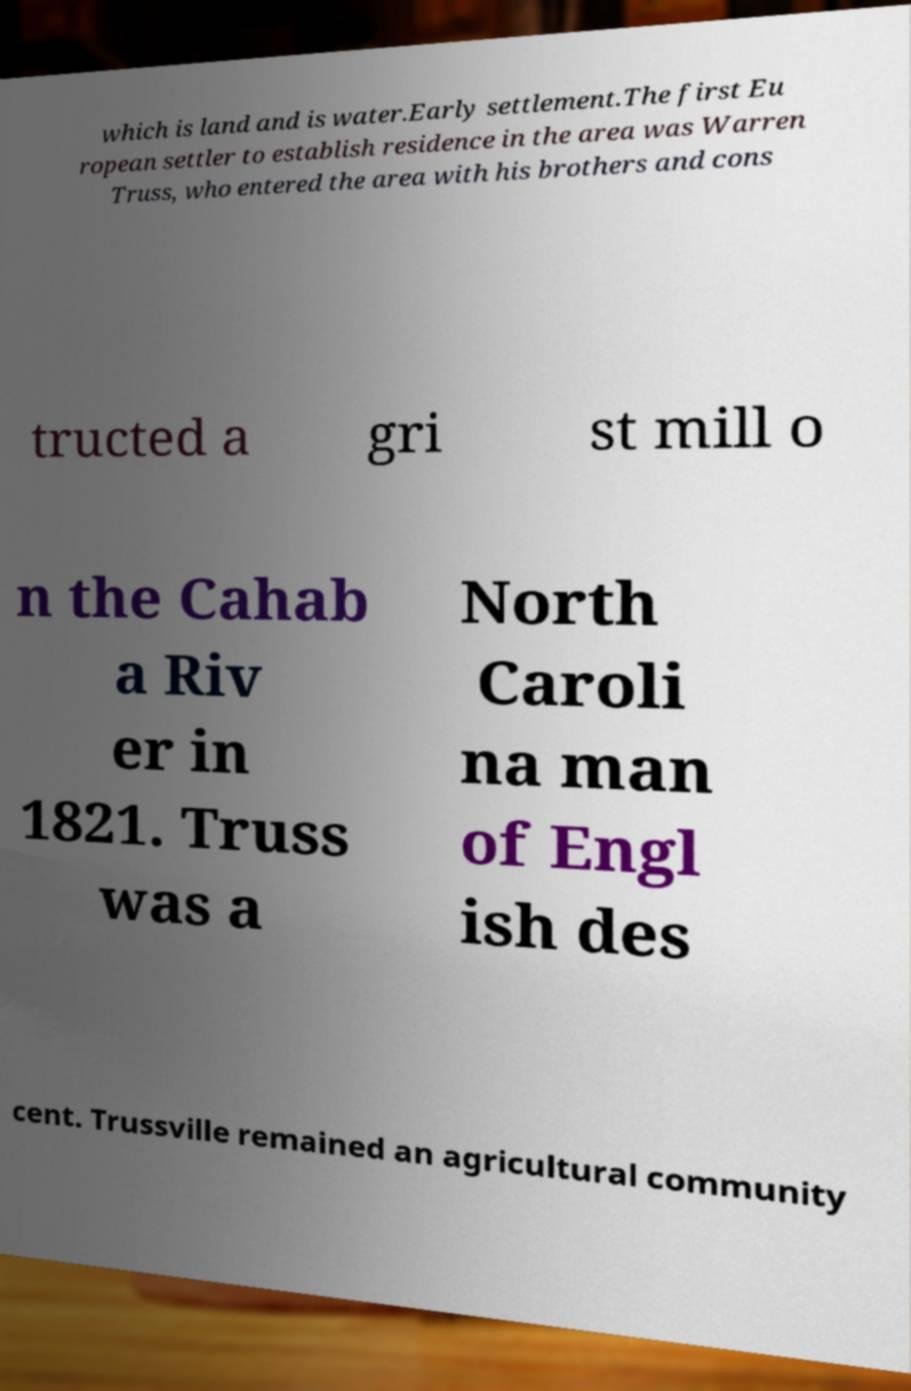Could you extract and type out the text from this image? which is land and is water.Early settlement.The first Eu ropean settler to establish residence in the area was Warren Truss, who entered the area with his brothers and cons tructed a gri st mill o n the Cahab a Riv er in 1821. Truss was a North Caroli na man of Engl ish des cent. Trussville remained an agricultural community 